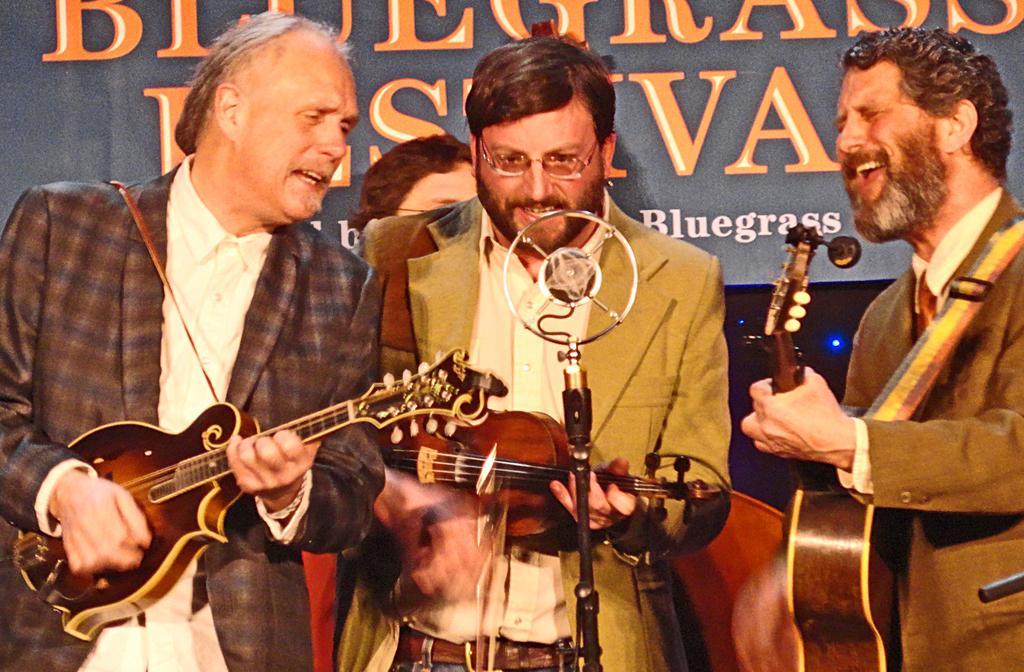Could you give a brief overview of what you see in this image? There are three persons holding three different musical instrument, the person in the middle with peach color jacket and in the left a person with brown color jacket singing and in the right is a person with brown color jacket at the back there is a banner. 